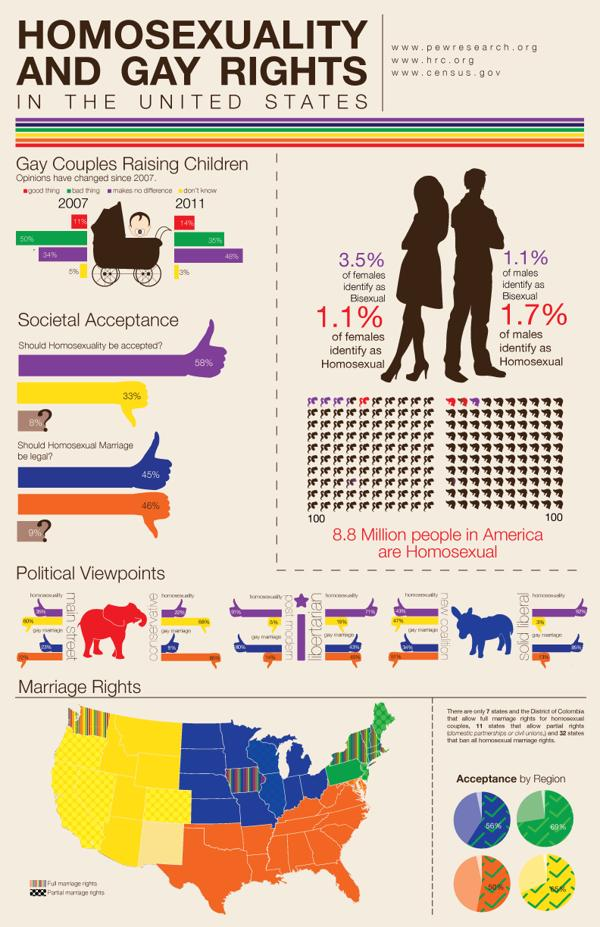Point out several critical features in this image. A recent survey has revealed that a majority of people in the United States, at 58%, believe that homosexuality should be accepted. According to a recent survey, 33% of people in the United States believe that homosexuality should not be accepted. The total homosexual population in the United States is approximately 8.8 million people. According to data in the United States, only 1.7% of males identify as homosexual. According to data in the United States, 1.1% of males are identified as bisexual. 